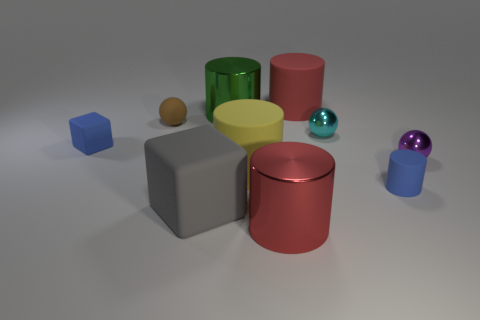What color is the tiny rubber thing right of the small sphere on the left side of the big matte cylinder behind the matte sphere? blue 